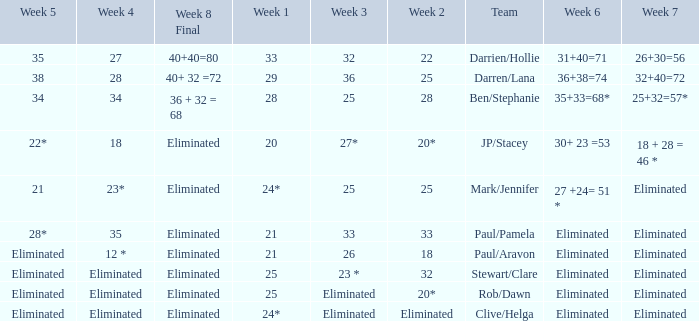Name the week 3 of 36 29.0. 